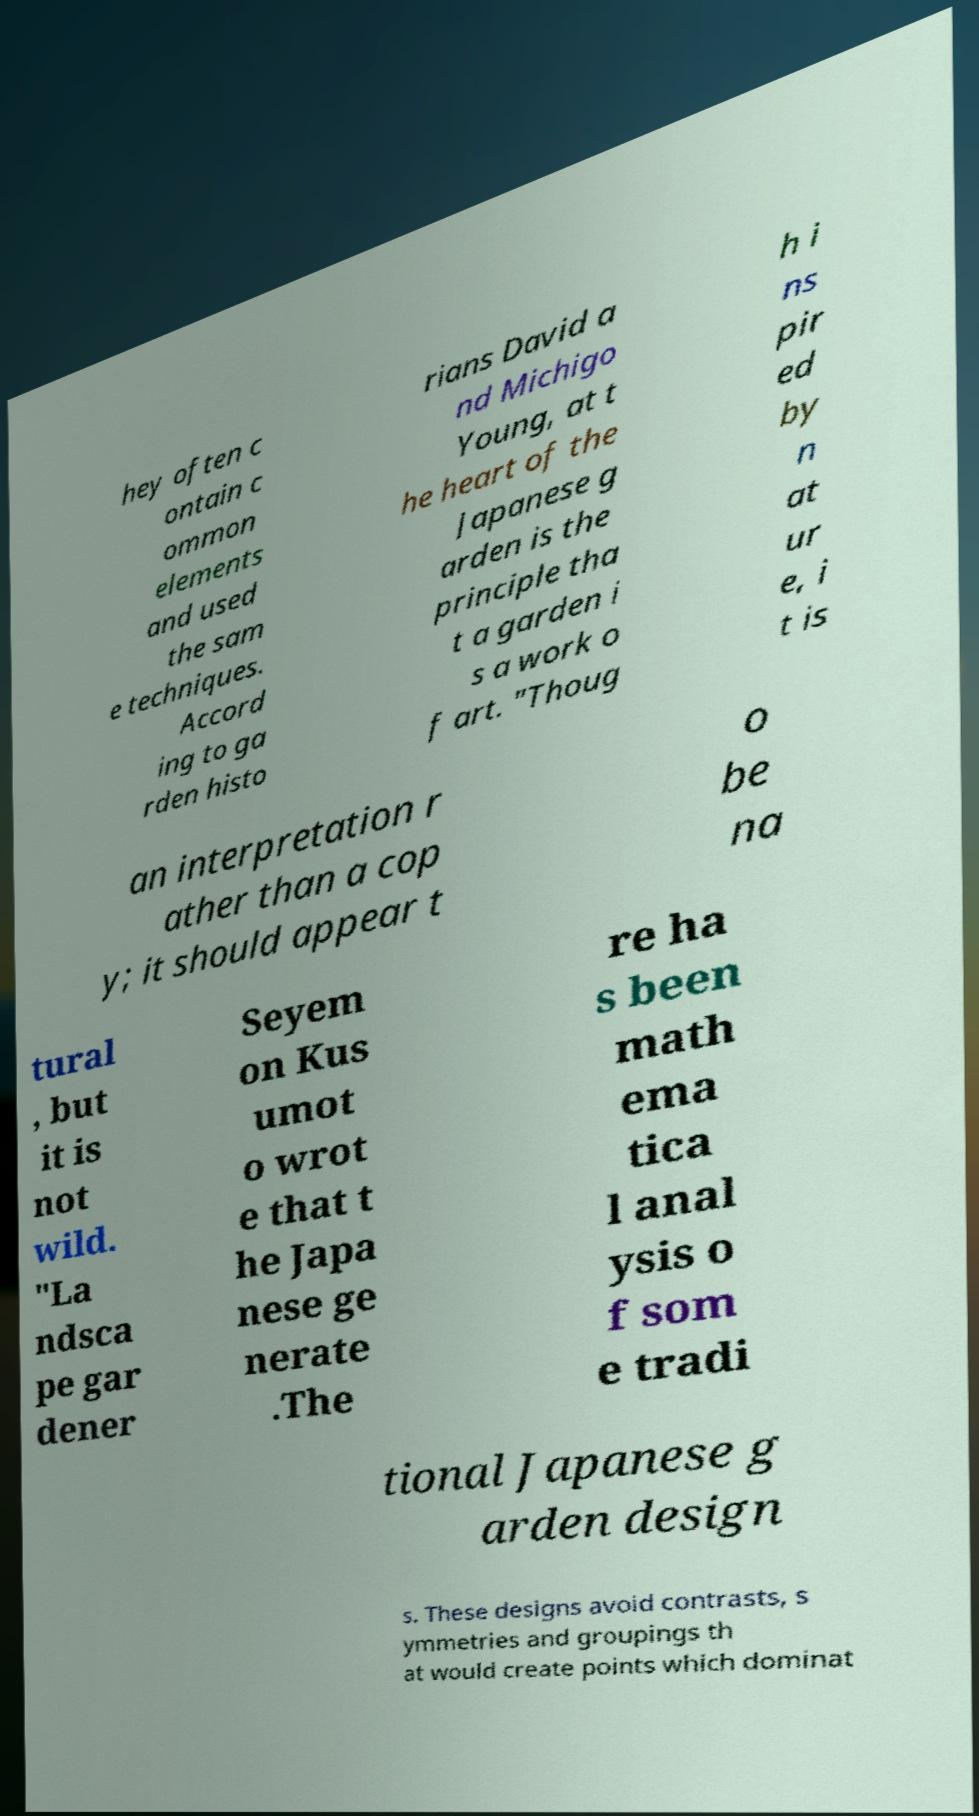Can you accurately transcribe the text from the provided image for me? hey often c ontain c ommon elements and used the sam e techniques. Accord ing to ga rden histo rians David a nd Michigo Young, at t he heart of the Japanese g arden is the principle tha t a garden i s a work o f art. "Thoug h i ns pir ed by n at ur e, i t is an interpretation r ather than a cop y; it should appear t o be na tural , but it is not wild. "La ndsca pe gar dener Seyem on Kus umot o wrot e that t he Japa nese ge nerate .The re ha s been math ema tica l anal ysis o f som e tradi tional Japanese g arden design s. These designs avoid contrasts, s ymmetries and groupings th at would create points which dominat 